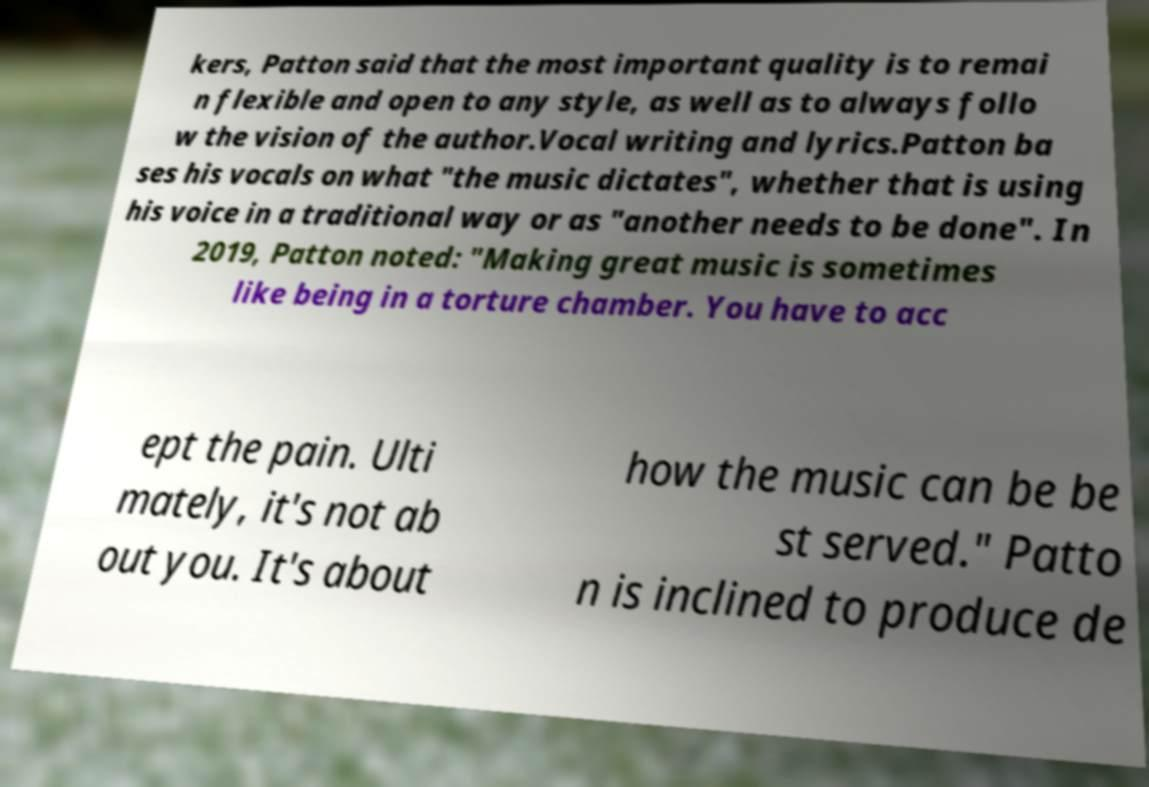Could you assist in decoding the text presented in this image and type it out clearly? kers, Patton said that the most important quality is to remai n flexible and open to any style, as well as to always follo w the vision of the author.Vocal writing and lyrics.Patton ba ses his vocals on what "the music dictates", whether that is using his voice in a traditional way or as "another needs to be done". In 2019, Patton noted: "Making great music is sometimes like being in a torture chamber. You have to acc ept the pain. Ulti mately, it's not ab out you. It's about how the music can be be st served." Patto n is inclined to produce de 